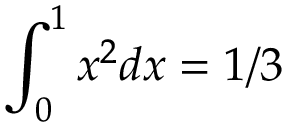Convert formula to latex. <formula><loc_0><loc_0><loc_500><loc_500>\int _ { 0 } ^ { 1 } x ^ { 2 } d x = 1 / 3</formula> 